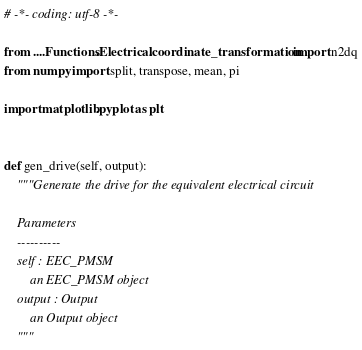Convert code to text. <code><loc_0><loc_0><loc_500><loc_500><_Python_># -*- coding: utf-8 -*-

from ....Functions.Electrical.coordinate_transformation import n2dq
from numpy import split, transpose, mean, pi

import matplotlib.pyplot as plt


def gen_drive(self, output):
    """Generate the drive for the equivalent electrical circuit

    Parameters
    ----------
    self : EEC_PMSM
        an EEC_PMSM object
    output : Output
        an Output object
    """
</code> 